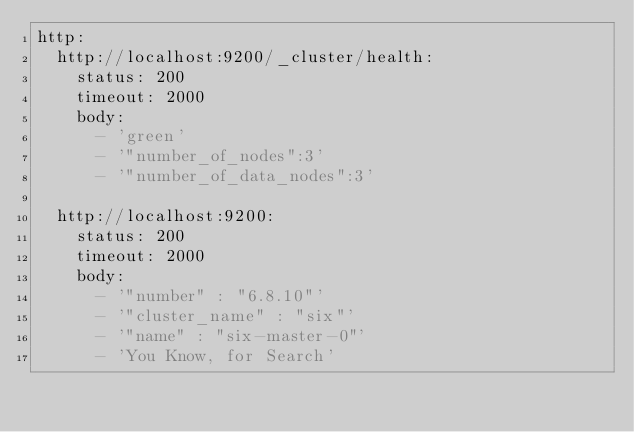<code> <loc_0><loc_0><loc_500><loc_500><_YAML_>http:
  http://localhost:9200/_cluster/health:
    status: 200
    timeout: 2000
    body:
      - 'green'
      - '"number_of_nodes":3'
      - '"number_of_data_nodes":3'

  http://localhost:9200:
    status: 200
    timeout: 2000
    body:
      - '"number" : "6.8.10"'
      - '"cluster_name" : "six"'
      - '"name" : "six-master-0"'
      - 'You Know, for Search'
</code> 